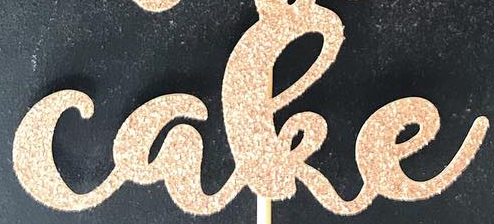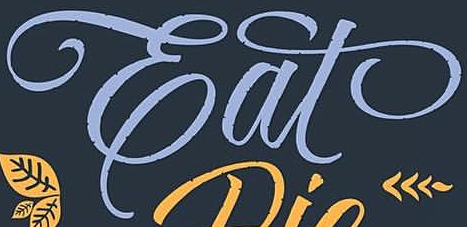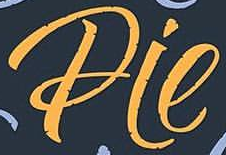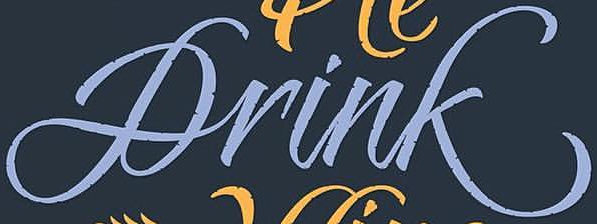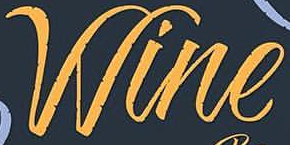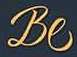What words are shown in these images in order, separated by a semicolon? cake; Eat; Pie; Drink; Wine; Be 